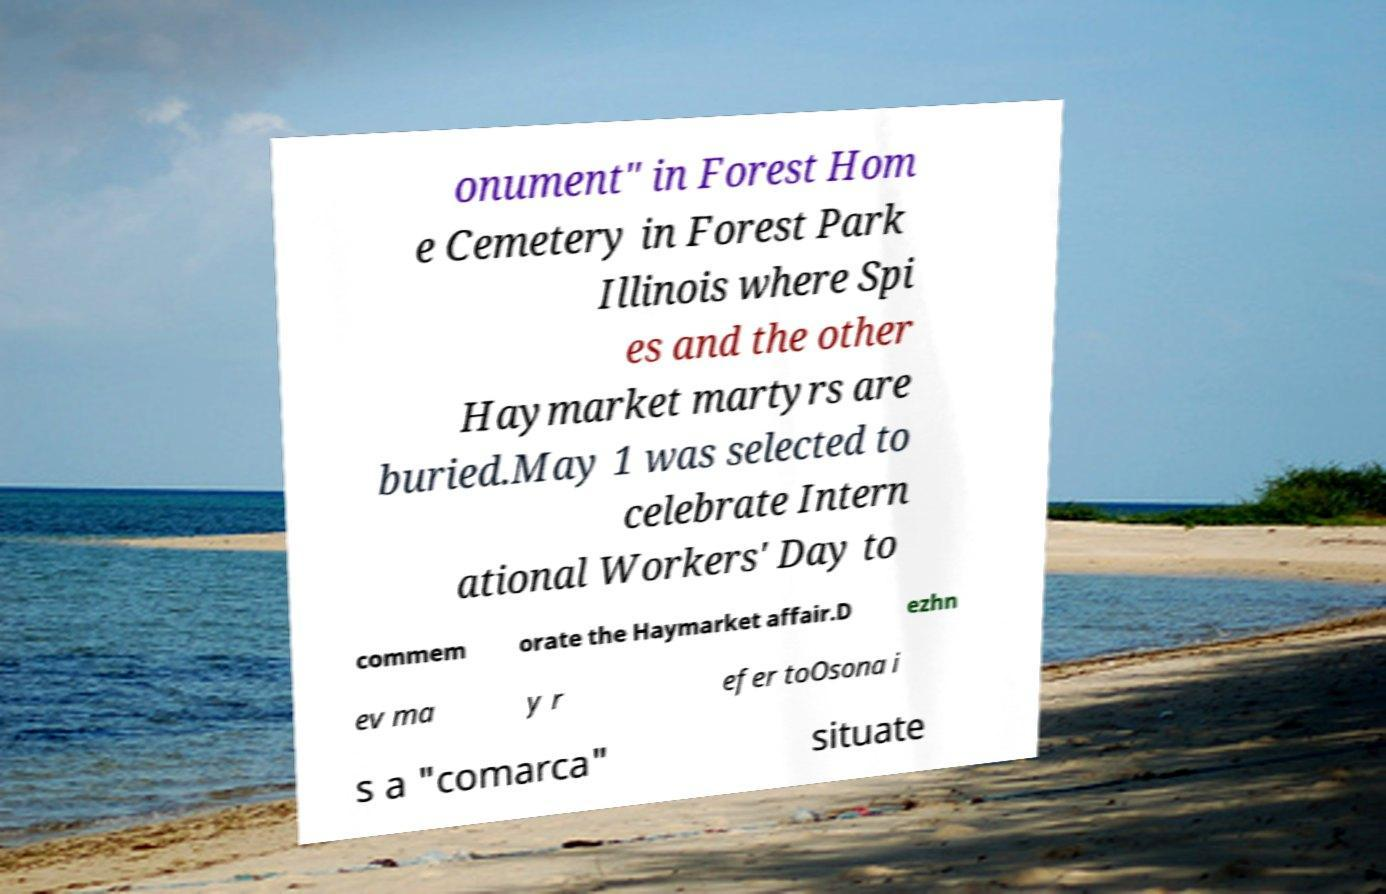For documentation purposes, I need the text within this image transcribed. Could you provide that? onument" in Forest Hom e Cemetery in Forest Park Illinois where Spi es and the other Haymarket martyrs are buried.May 1 was selected to celebrate Intern ational Workers' Day to commem orate the Haymarket affair.D ezhn ev ma y r efer toOsona i s a "comarca" situate 